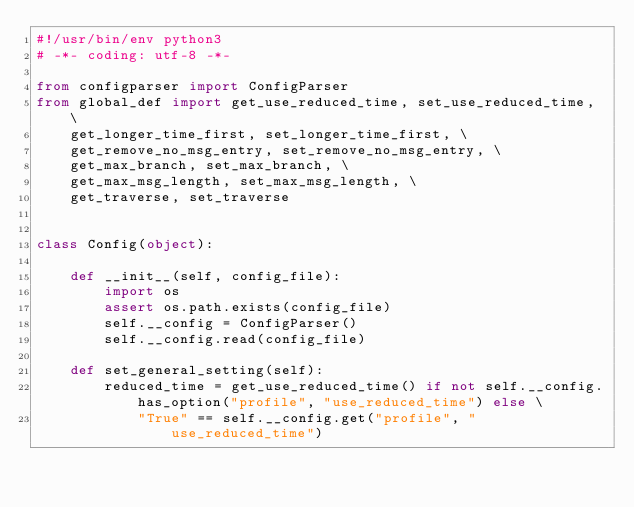Convert code to text. <code><loc_0><loc_0><loc_500><loc_500><_Python_>#!/usr/bin/env python3
# -*- coding: utf-8 -*-

from configparser import ConfigParser
from global_def import get_use_reduced_time, set_use_reduced_time, \
    get_longer_time_first, set_longer_time_first, \
    get_remove_no_msg_entry, set_remove_no_msg_entry, \
    get_max_branch, set_max_branch, \
    get_max_msg_length, set_max_msg_length, \
    get_traverse, set_traverse


class Config(object):

    def __init__(self, config_file):
        import os
        assert os.path.exists(config_file)
        self.__config = ConfigParser()
        self.__config.read(config_file)

    def set_general_setting(self):
        reduced_time = get_use_reduced_time() if not self.__config.has_option("profile", "use_reduced_time") else \
            "True" == self.__config.get("profile", "use_reduced_time")</code> 